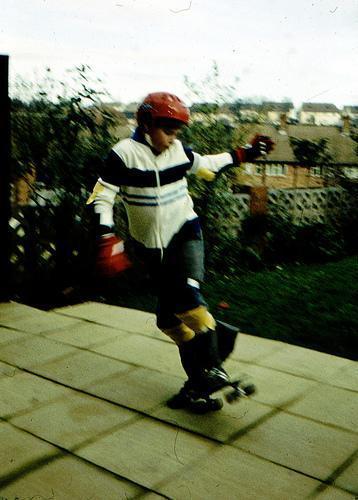How many people are pictured?
Give a very brief answer. 1. How many kids are on a skateboard?
Give a very brief answer. 1. 